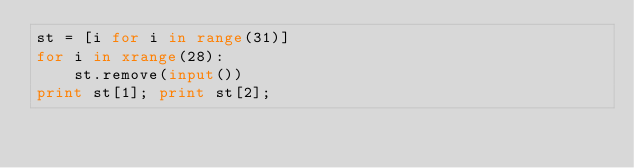<code> <loc_0><loc_0><loc_500><loc_500><_Python_>st = [i for i in range(31)]
for i in xrange(28):
    st.remove(input())
print st[1]; print st[2];</code> 